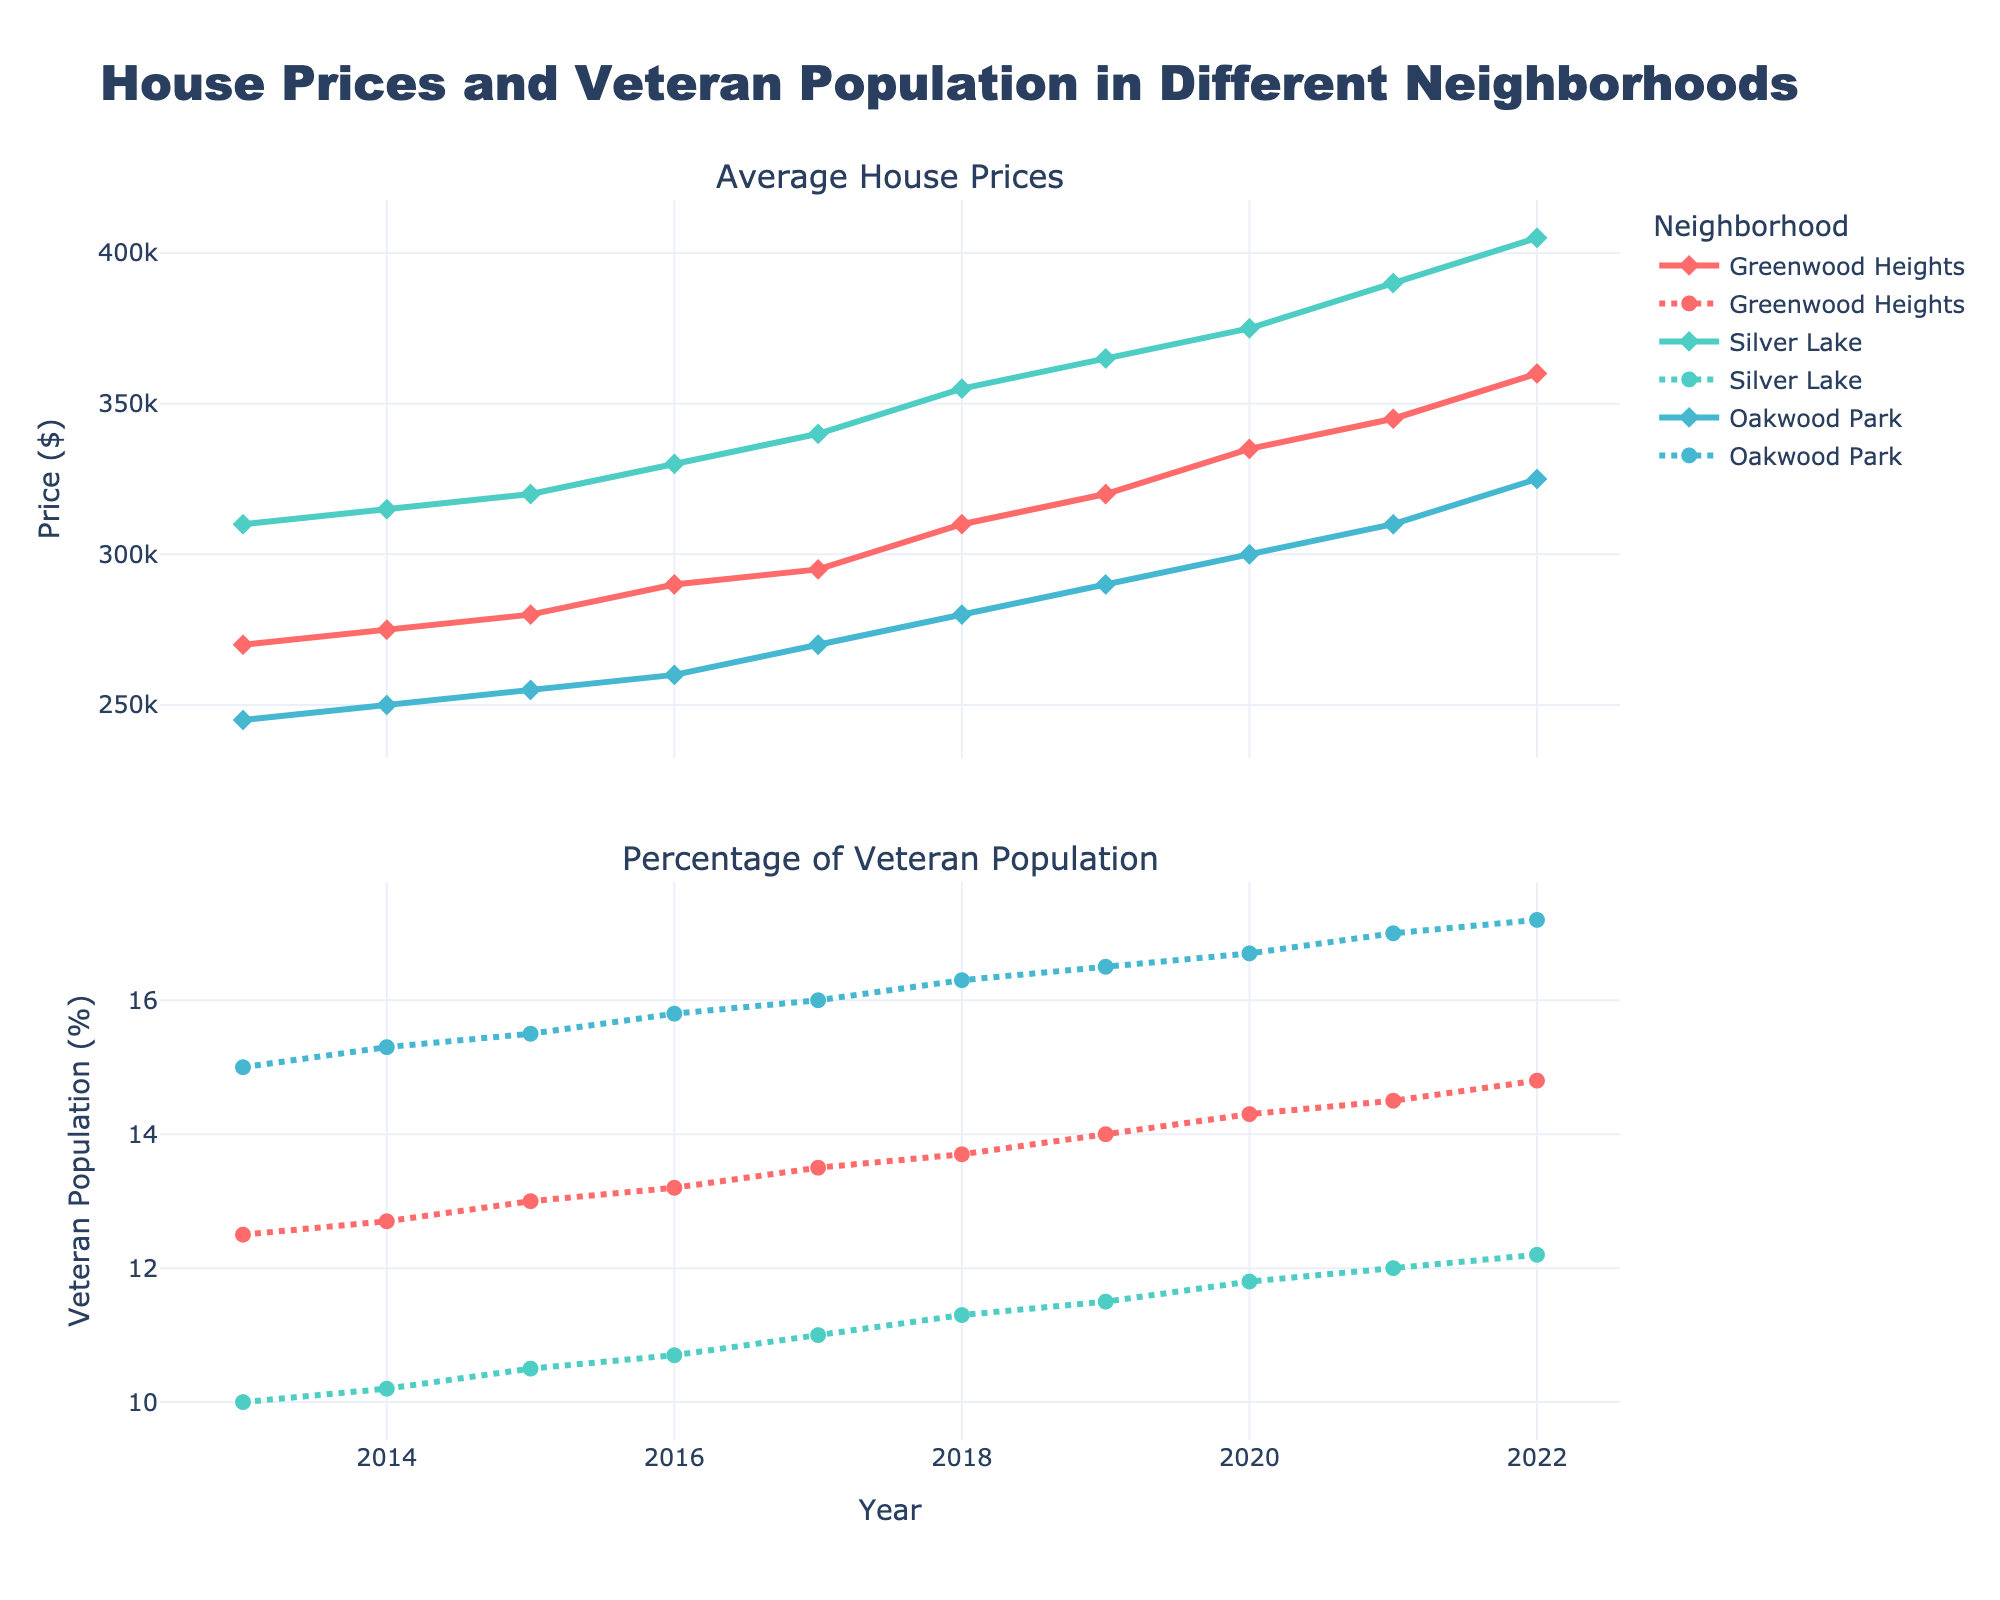What's the title of the plot? The title of the plot is located at the top center and is meant to give an overview of what the plot is about. The title reads: "House Prices and Veteran Population in Different Neighborhoods".
Answer: House Prices and Veteran Population in Different Neighborhoods What is the highest average house price recorded in the Greenwood Heights neighborhood over the past 10 years? To find the highest average house price, locate the lines corresponding to Greenwood Heights in the top subplot and identify the highest point. The highest price in Greenwood Heights is $360,000 in 2022.
Answer: $360,000 Between 2013 and 2022, which neighborhood had the most significant increase in average house prices? Compare the starting and ending house prices in each neighborhood. For Greenwood Heights: $360,000 - $270,000 = $90,000 increase; Silver Lake: $405,000 - $310,000 = $95,000 increase; Oakwood Park: $325,000 - $245,000 = $80,000 increase. Silver Lake had the most significant increase.
Answer: Silver Lake In which year did Oakwood Park have the highest percentage of the veteran population? Locate the line corresponding to Oakwood Park in the bottom subplot and identify the point with the highest value. The highest percentage for Oakwood Park is seen in 2022 with 17.2%.
Answer: 2022 How does the percentage of the veteran population in Silver Lake change from 2013 to 2022? Check the line corresponding to Silver Lake in the bottom subplot and compare the values from 2013 and 2022. The percentage increases from 10% in 2013 to 12.2% in 2022.
Answer: It increases from 10% to 12.2% Which neighborhood had the most veteran population as a percentage in 2016? Compare the 2016 values in the bottom subplot for all neighborhoods. Oakwood Park had the highest percentage of 15.8% in 2016.
Answer: Oakwood Park By how much did the average house price in Silver Lake increase between 2013 and 2016? Identify the average house prices in Silver Lake for 2013 ($310,000) and 2016 ($330,000). Subtract the 2013 value from the 2016 value: $330,000 - $310,000 = $20,000 increase.
Answer: $20,000 Across the entire period from 2013 to 2022, which neighborhood shows the most consistent increase in house prices? Observe the plot lines in the top subplot to see which one shows a steady upward trend without major fluctuations. Greenwood Heights shows the most consistent increase.
Answer: Greenwood Heights Comparing Greenwood Heights and Oakwood Park, which neighborhood had a higher average house price in 2020? Look at 2020's data points on the top subplot for both neighborhoods. Greenwood Heights had an average price of $335,000, and Oakwood Park had $300,000. Greenwood Heights had the higher price.
Answer: Greenwood Heights 